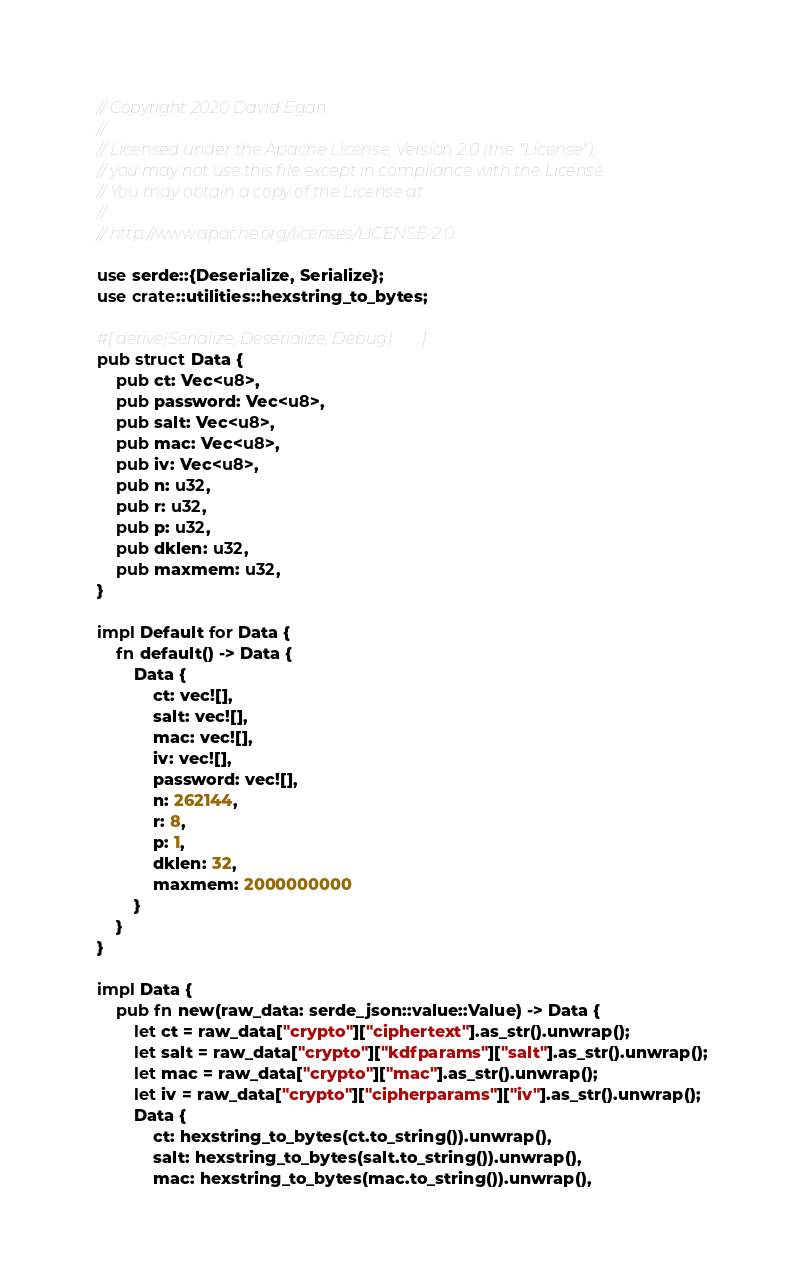Convert code to text. <code><loc_0><loc_0><loc_500><loc_500><_Rust_>// Copyright 2020 David Egan
// 
// Licensed under the Apache License, Version 2.0 (the "License");
// you may not use this file except in compliance with the License.
// You may obtain a copy of the License at
// 
// http://www.apache.org/licenses/LICENSE-2.0

use serde::{Deserialize, Serialize};
use crate::utilities::hexstring_to_bytes;

#[derive(Serialize, Deserialize, Debug)]
pub struct Data {
    pub ct: Vec<u8>,
    pub password: Vec<u8>,
    pub salt: Vec<u8>, 
    pub mac: Vec<u8>,
    pub iv: Vec<u8>,
    pub n: u32, 
    pub r: u32, 
    pub p: u32, 
    pub dklen: u32, 
    pub maxmem: u32,
}

impl Default for Data {
    fn default() -> Data {
        Data {
            ct: vec![],
            salt: vec![], 
            mac: vec![],
            iv: vec![],
            password: vec![],
            n: 262144, 
            r: 8,
            p: 1,
            dklen: 32,
            maxmem: 2000000000
        }
    }
}

impl Data {
    pub fn new(raw_data: serde_json::value::Value) -> Data {
        let ct = raw_data["crypto"]["ciphertext"].as_str().unwrap();
        let salt = raw_data["crypto"]["kdfparams"]["salt"].as_str().unwrap();
        let mac = raw_data["crypto"]["mac"].as_str().unwrap();
        let iv = raw_data["crypto"]["cipherparams"]["iv"].as_str().unwrap();
        Data {
            ct: hexstring_to_bytes(ct.to_string()).unwrap(),
            salt: hexstring_to_bytes(salt.to_string()).unwrap(), 
            mac: hexstring_to_bytes(mac.to_string()).unwrap(),</code> 